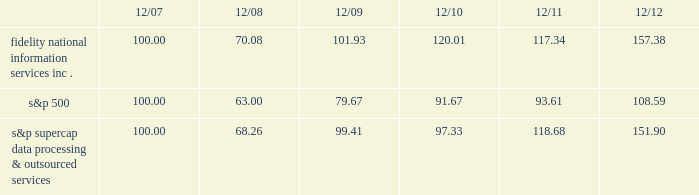
S&p supercap data processing & outsourced 100.00 68.26 99.41 97.33 118.68 151.90 item 6 .
Selected financial data .
The selected financial data set forth below constitutes historical financial data of fis and should be read in conjunction with item 7 , management 2019s discussion and analysis of financial condition and results of operations , and item 8 , financial statements and supplementary data , included elsewhere in this report .
On october 1 , 2009 , we completed the acquisition of metavante technologies , inc .
( "metavante" ) .
The results of operations and financial position of metavante are included in the consolidated financial statements since the date of acquisition .
On july 2 , 2008 , we completed the spin-off of lender processing services , inc. , which was a former wholly-owned subsidiary ( "lps" ) .
For accounting purposes , the results of lps are presented as discontinued operations .
Accordingly , all prior periods have been restated to present the results of fis on a stand alone basis and include the results of lps up to july 2 , 2008 , as discontinued operations. .
What was the percentage cumulative 5-year total shareholder return on common stock fidelity national information services , inc . for the period ending 12/12? 
Computations: ((157.38 - 100) / 100)
Answer: 0.5738. 